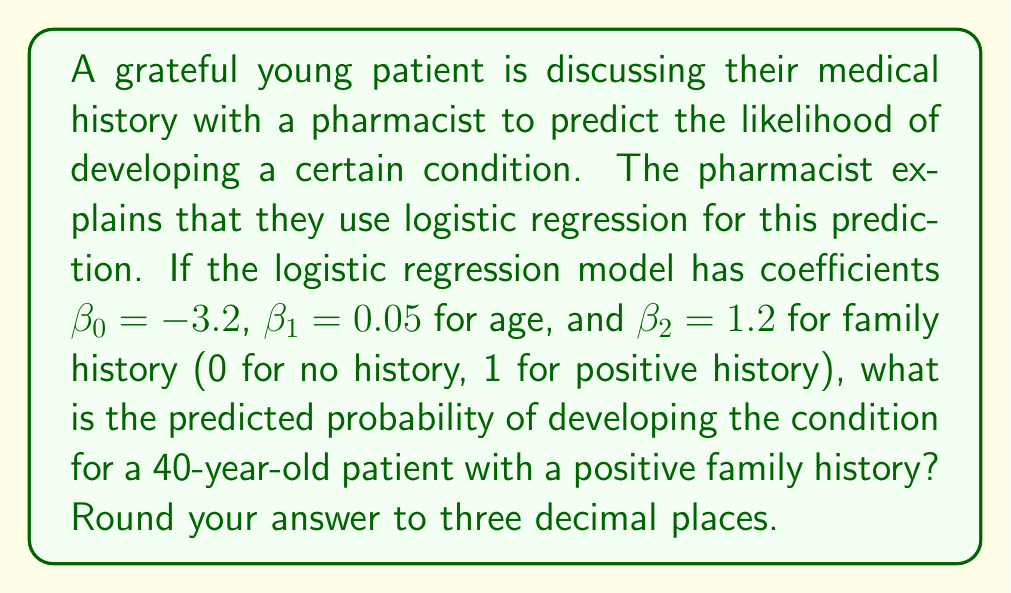Show me your answer to this math problem. Let's approach this step-by-step:

1) The logistic regression model uses the logistic function:

   $$P(Y=1) = \frac{1}{1 + e^{-z}}$$

   where $z = \beta_0 + \beta_1x_1 + \beta_2x_2 + ... + \beta_nx_n$

2) In this case, we have:
   $\beta_0 = -3.2$ (intercept)
   $\beta_1 = 0.05$ (coefficient for age)
   $\beta_2 = 1.2$ (coefficient for family history)

3) The patient's data:
   $x_1 = 40$ (age)
   $x_2 = 1$ (positive family history)

4) Let's calculate $z$:
   
   $$z = -3.2 + 0.05(40) + 1.2(1)$$
   $$z = -3.2 + 2 + 1.2$$
   $$z = 0$$

5) Now, let's plug this into the logistic function:

   $$P(Y=1) = \frac{1}{1 + e^{-0}}$$
   $$P(Y=1) = \frac{1}{1 + 1}$$
   $$P(Y=1) = \frac{1}{2} = 0.5$$

6) Rounding to three decimal places: 0.500

The patient should be grateful for this detailed analysis provided by the pharmacist.
Answer: 0.500 